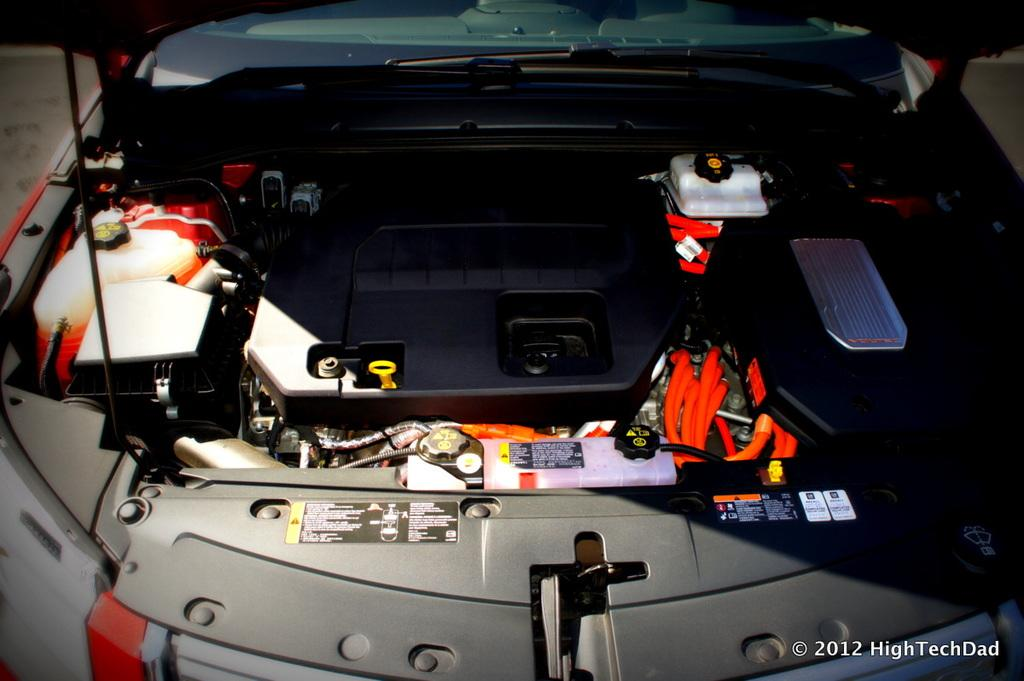What is the main subject of the picture? The main subject of the picture is an engine of a vehicle. What is the color of the engine? The engine is in grey color. Are there any visible wires in the picture? Yes, there are red color wires visible in the picture. Is there any additional marking or feature on the image? Yes, there is a watermark on the right bottom side of the image. What type of jewel is placed inside the mailbox in the image? There is no jewel or mailbox present in the image; it features an engine of a vehicle with red color wires and a watermark. 